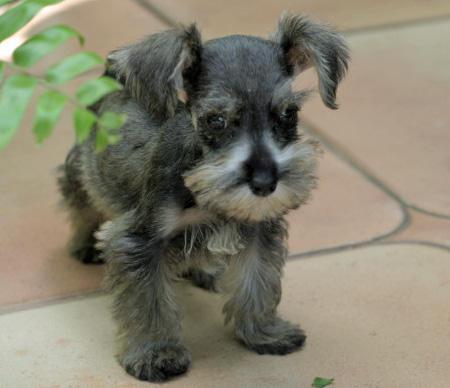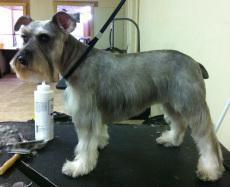The first image is the image on the left, the second image is the image on the right. Given the left and right images, does the statement "There is a dog wearing a collar and facing left in one image." hold true? Answer yes or no. Yes. The first image is the image on the left, the second image is the image on the right. Assess this claim about the two images: "There are two dogs sitting down.". Correct or not? Answer yes or no. No. 